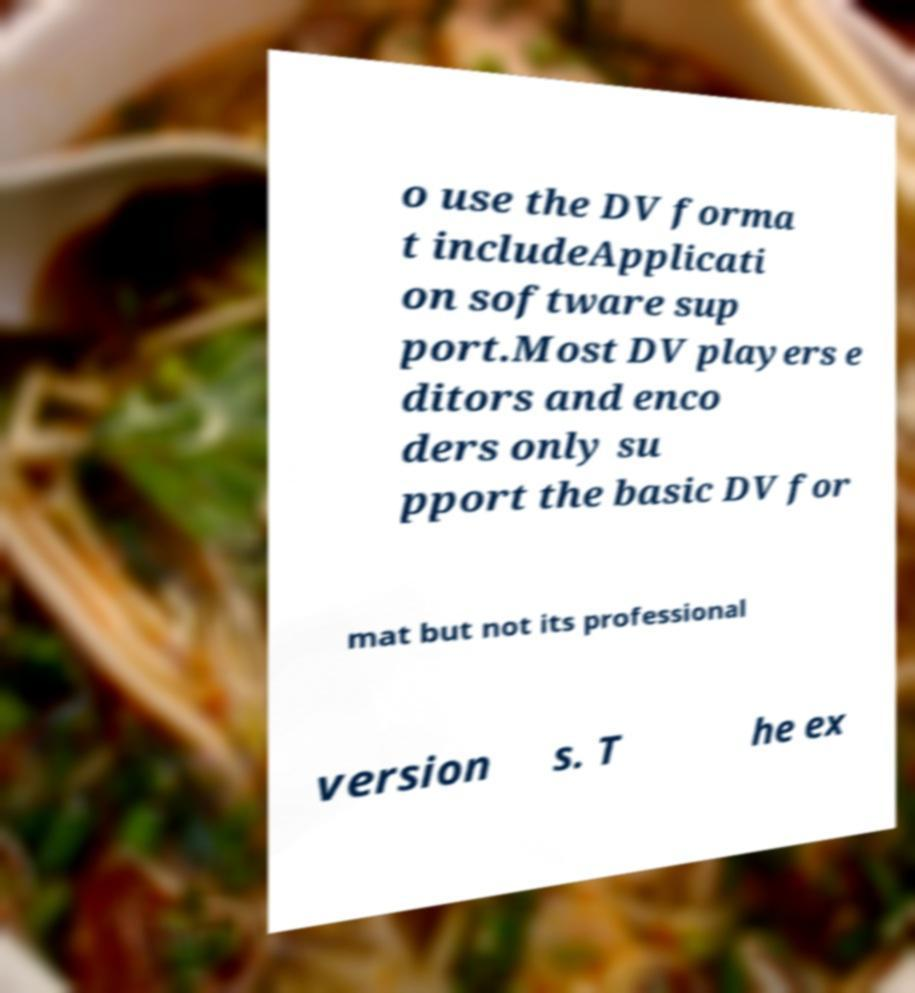I need the written content from this picture converted into text. Can you do that? o use the DV forma t includeApplicati on software sup port.Most DV players e ditors and enco ders only su pport the basic DV for mat but not its professional version s. T he ex 